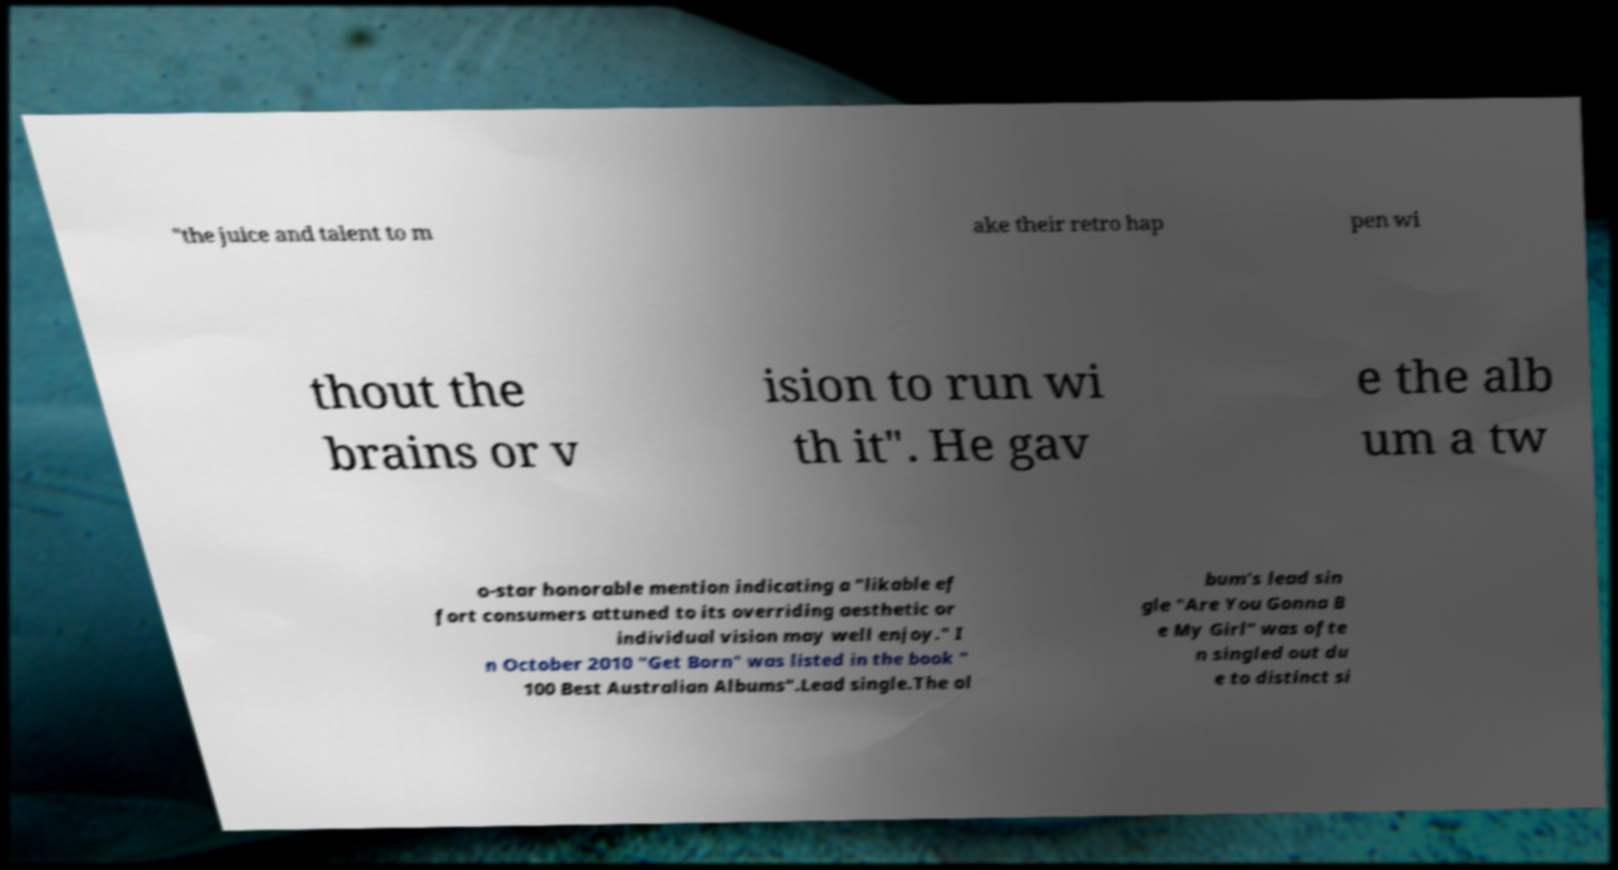Please identify and transcribe the text found in this image. "the juice and talent to m ake their retro hap pen wi thout the brains or v ision to run wi th it". He gav e the alb um a tw o-star honorable mention indicating a "likable ef fort consumers attuned to its overriding aesthetic or individual vision may well enjoy." I n October 2010 "Get Born" was listed in the book " 100 Best Australian Albums".Lead single.The al bum's lead sin gle "Are You Gonna B e My Girl" was ofte n singled out du e to distinct si 